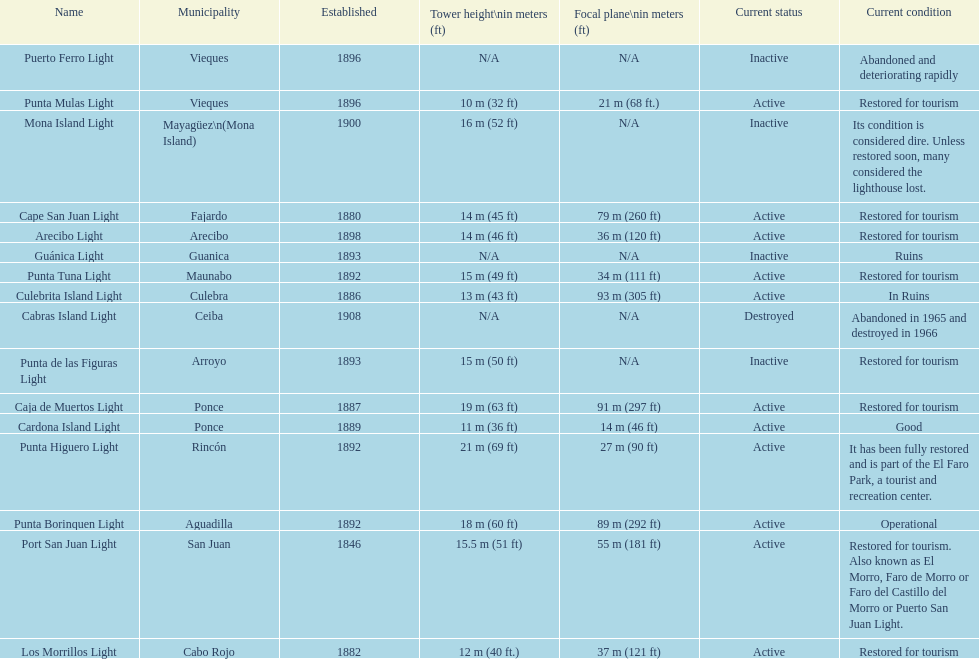Which municipality was the first to be established? San Juan. 